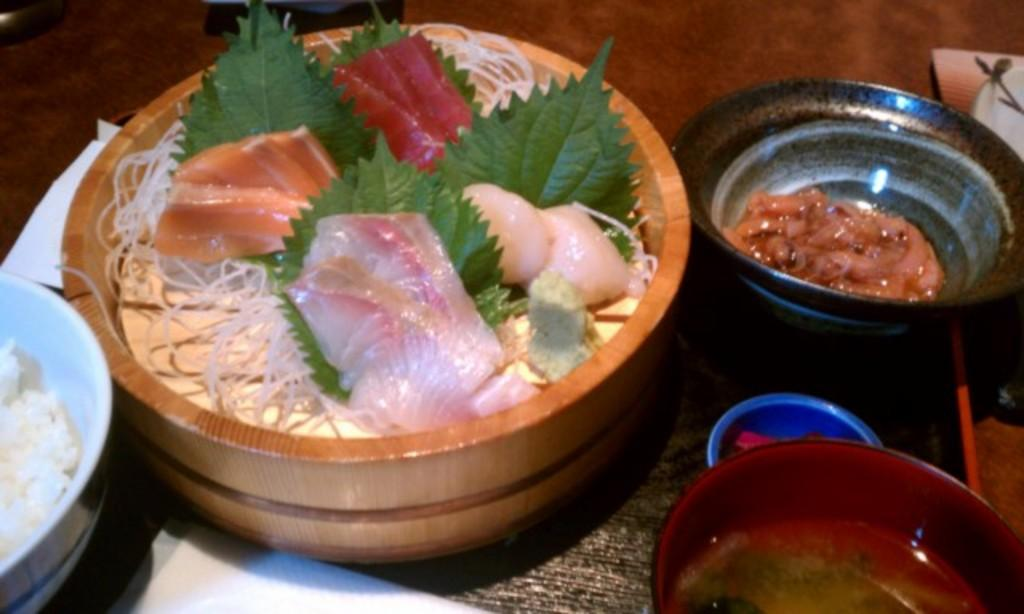What objects are present in the image? There are containers in the image. What is inside the containers? The containers contain food. What type of headwear is the person wearing in the image? There is no person present in the image, only containers containing food. 